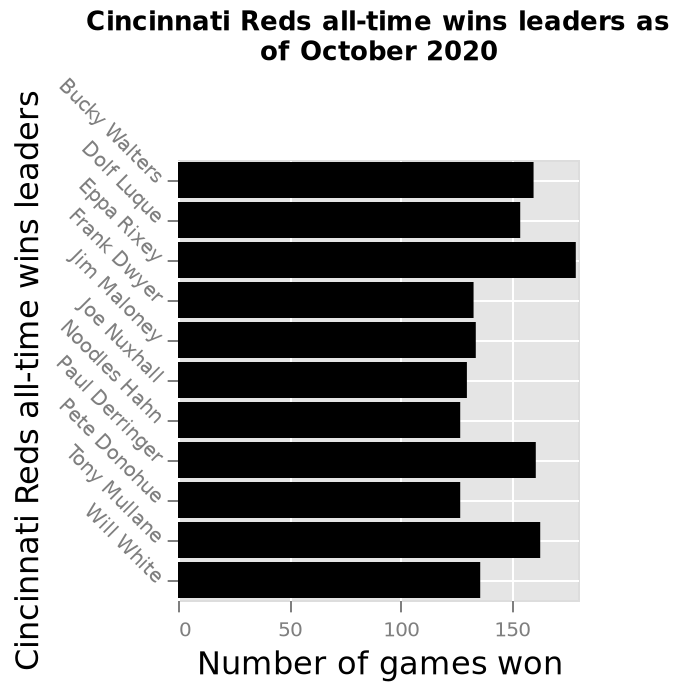<image>
What is the title of the y-axis in the bar plot? The title of the y-axis in the bar plot is "Cincinnati Reds all-time wins leaders". 